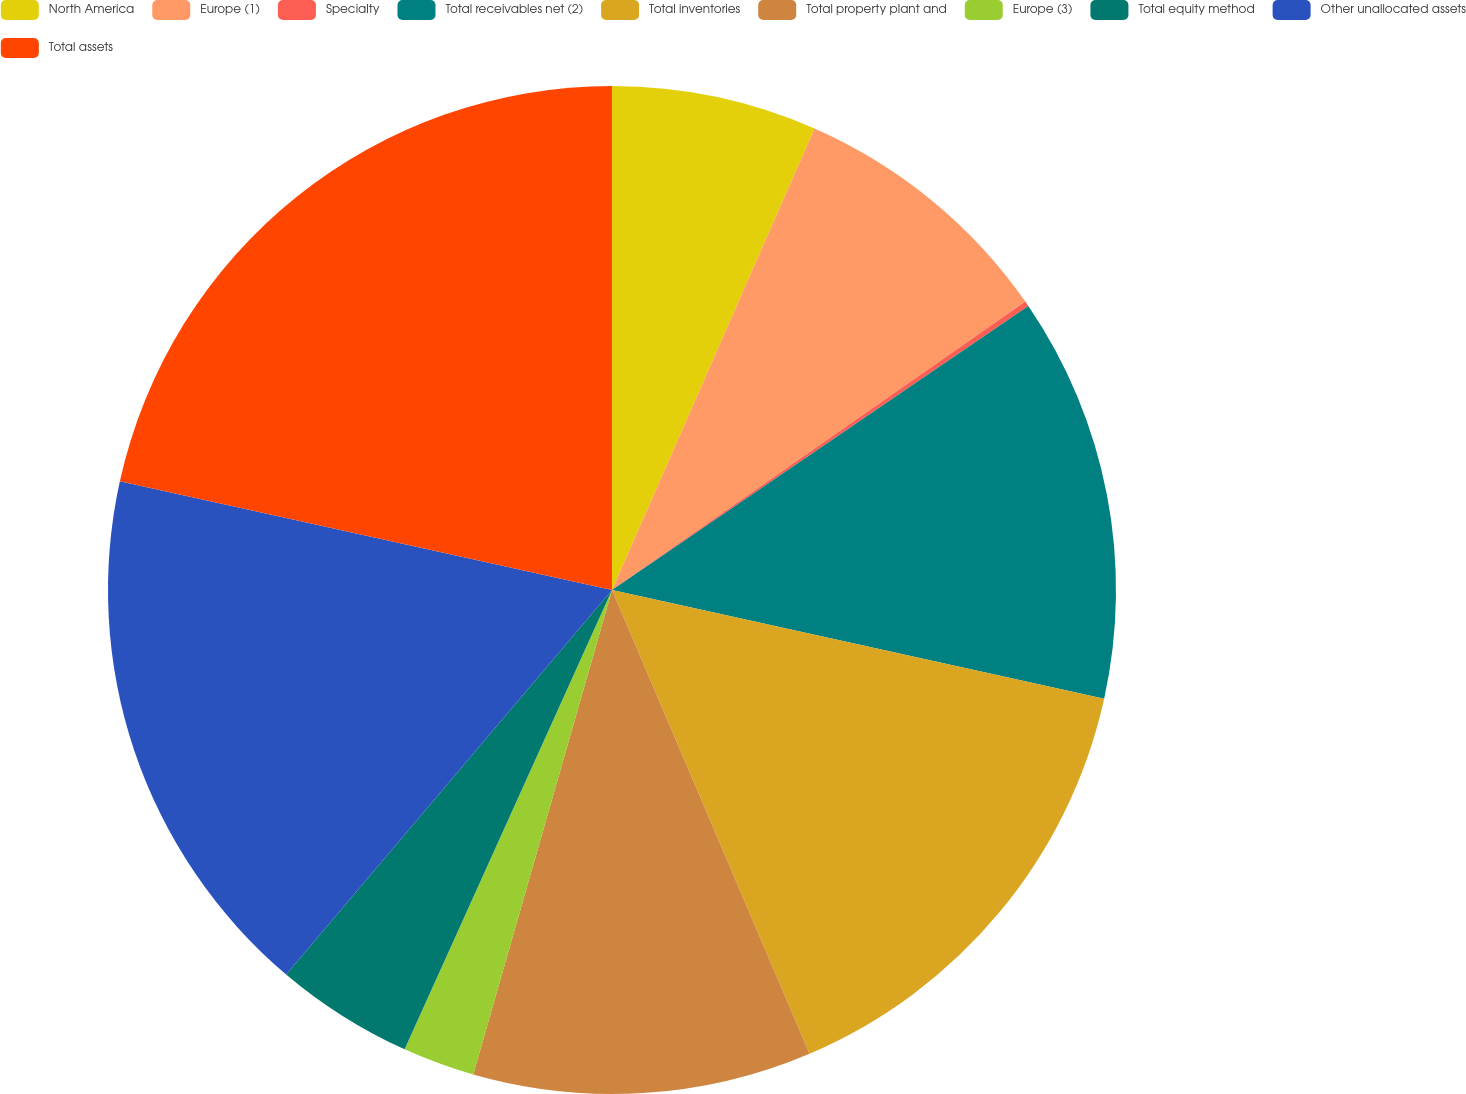Convert chart to OTSL. <chart><loc_0><loc_0><loc_500><loc_500><pie_chart><fcel>North America<fcel>Europe (1)<fcel>Specialty<fcel>Total receivables net (2)<fcel>Total inventories<fcel>Total property plant and<fcel>Europe (3)<fcel>Total equity method<fcel>Other unallocated assets<fcel>Total assets<nl><fcel>6.58%<fcel>8.72%<fcel>0.17%<fcel>12.99%<fcel>15.13%<fcel>10.85%<fcel>2.31%<fcel>4.44%<fcel>17.27%<fcel>21.54%<nl></chart> 